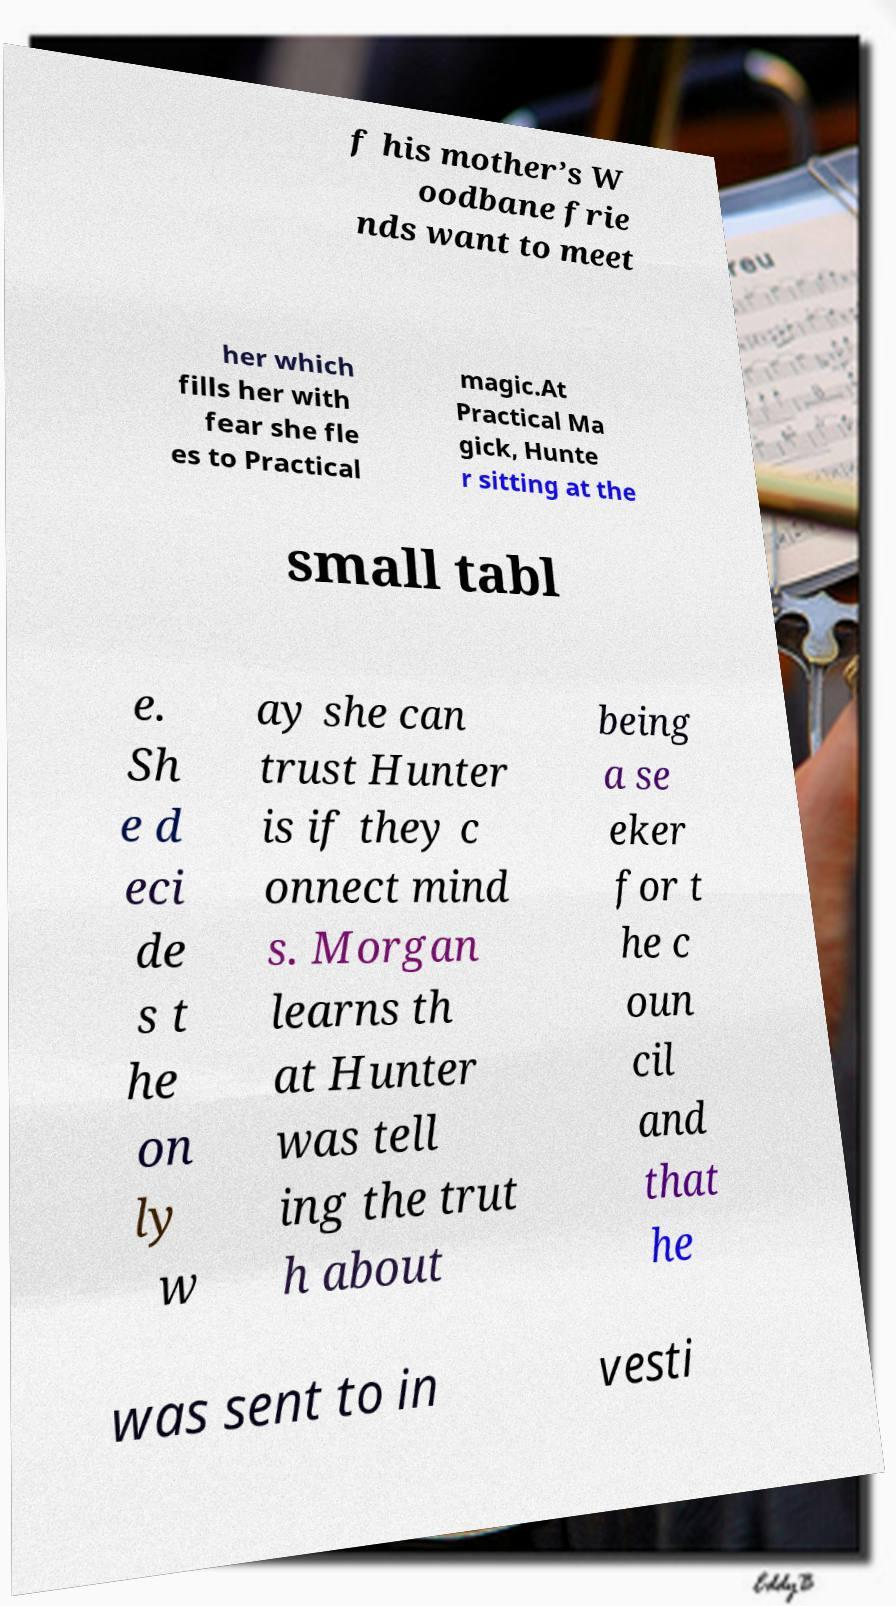Could you extract and type out the text from this image? f his mother’s W oodbane frie nds want to meet her which fills her with fear she fle es to Practical magic.At Practical Ma gick, Hunte r sitting at the small tabl e. Sh e d eci de s t he on ly w ay she can trust Hunter is if they c onnect mind s. Morgan learns th at Hunter was tell ing the trut h about being a se eker for t he c oun cil and that he was sent to in vesti 